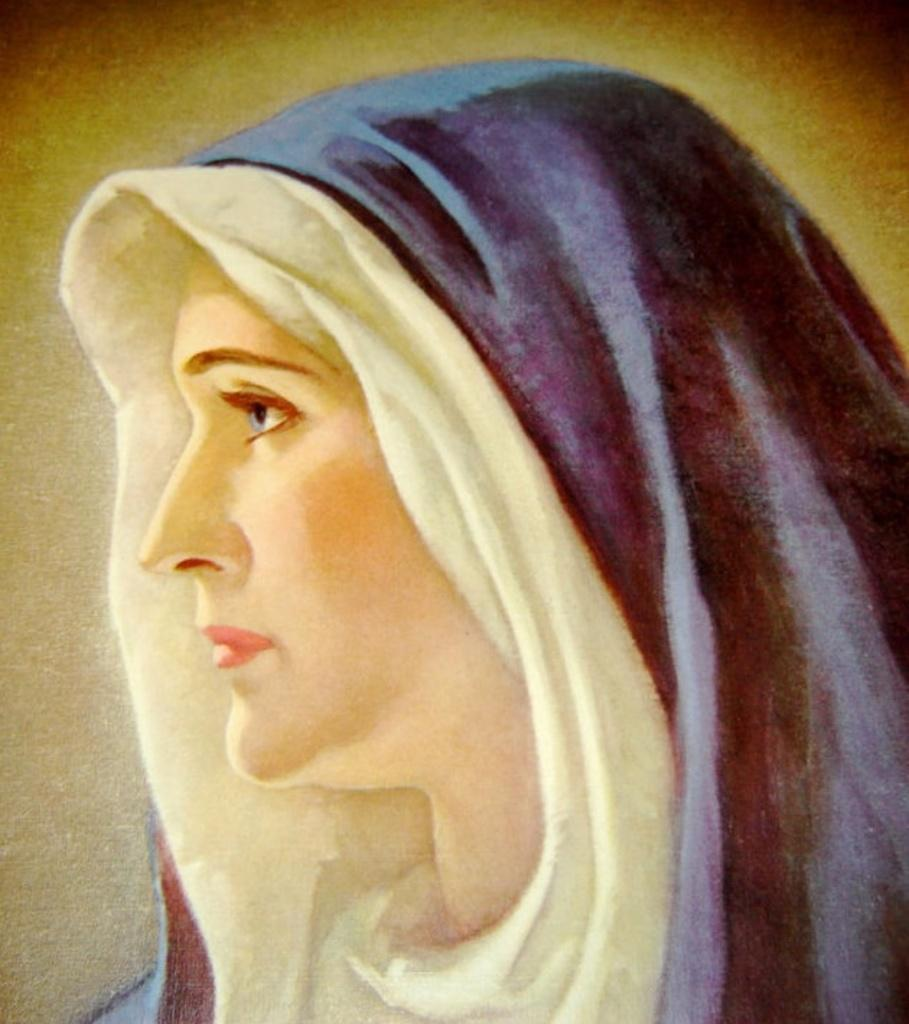What is the main subject of the painting in the image? There is a painting of a person in the image. How many straws are used to create the peace symbol in the painting? There is no straw or peace symbol present in the painting; it features a person. How many dogs are depicted in the painting? There are no dogs depicted in the painting; it features a person. 